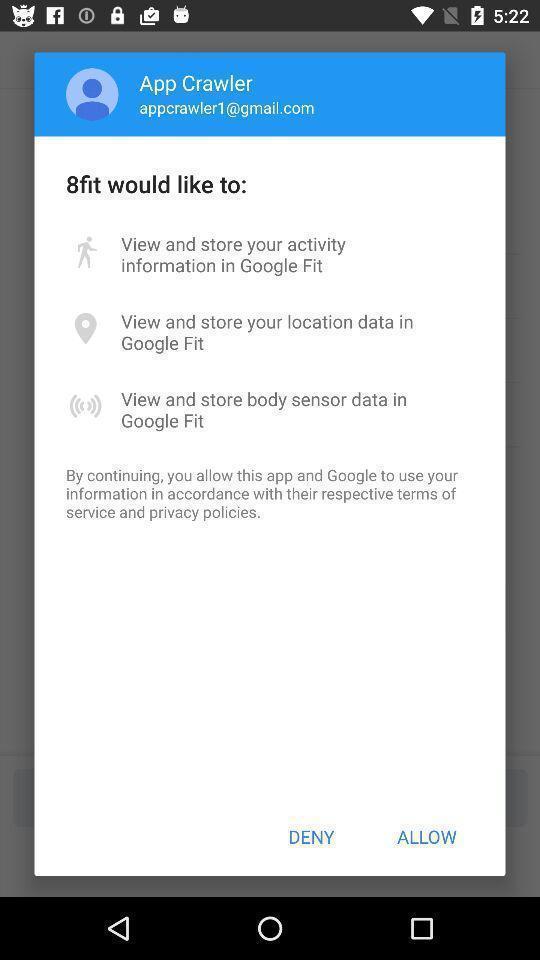Please provide a description for this image. Popup showing deny and allow option. 